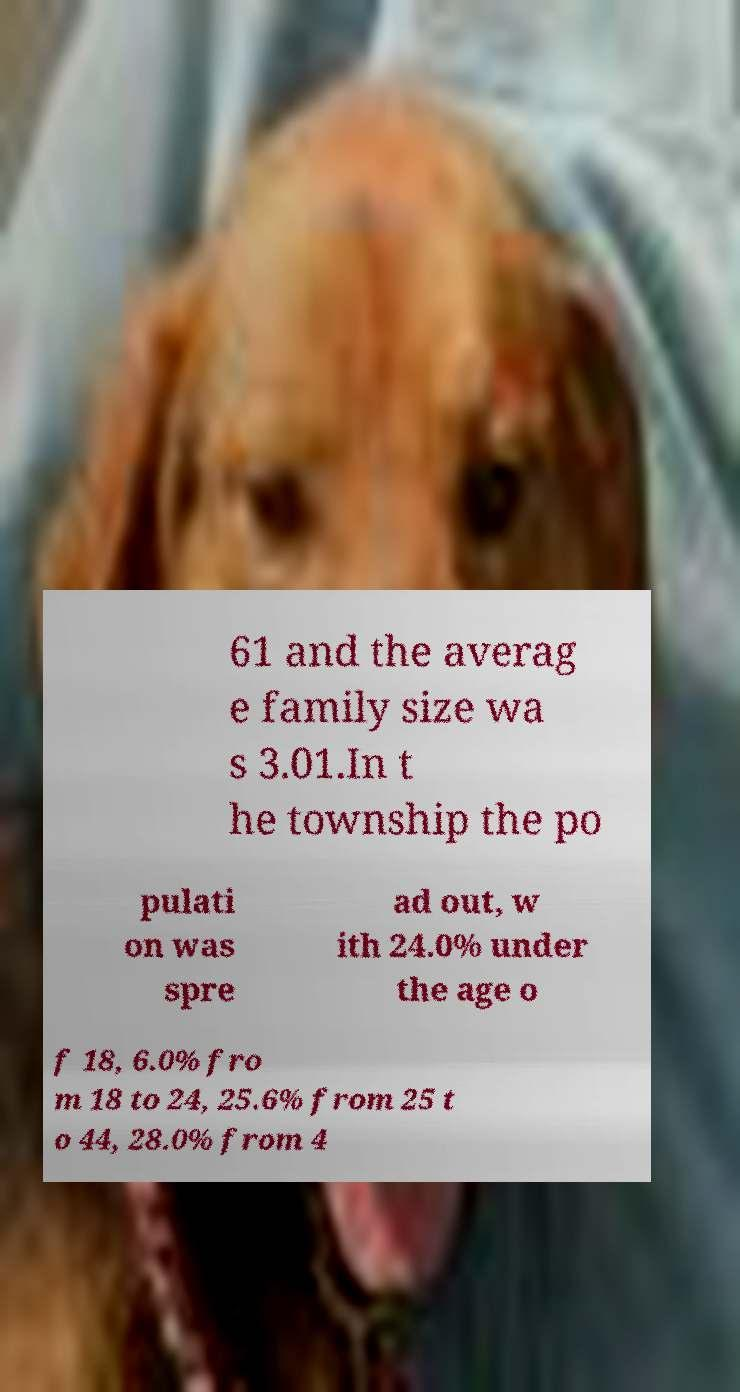For documentation purposes, I need the text within this image transcribed. Could you provide that? 61 and the averag e family size wa s 3.01.In t he township the po pulati on was spre ad out, w ith 24.0% under the age o f 18, 6.0% fro m 18 to 24, 25.6% from 25 t o 44, 28.0% from 4 